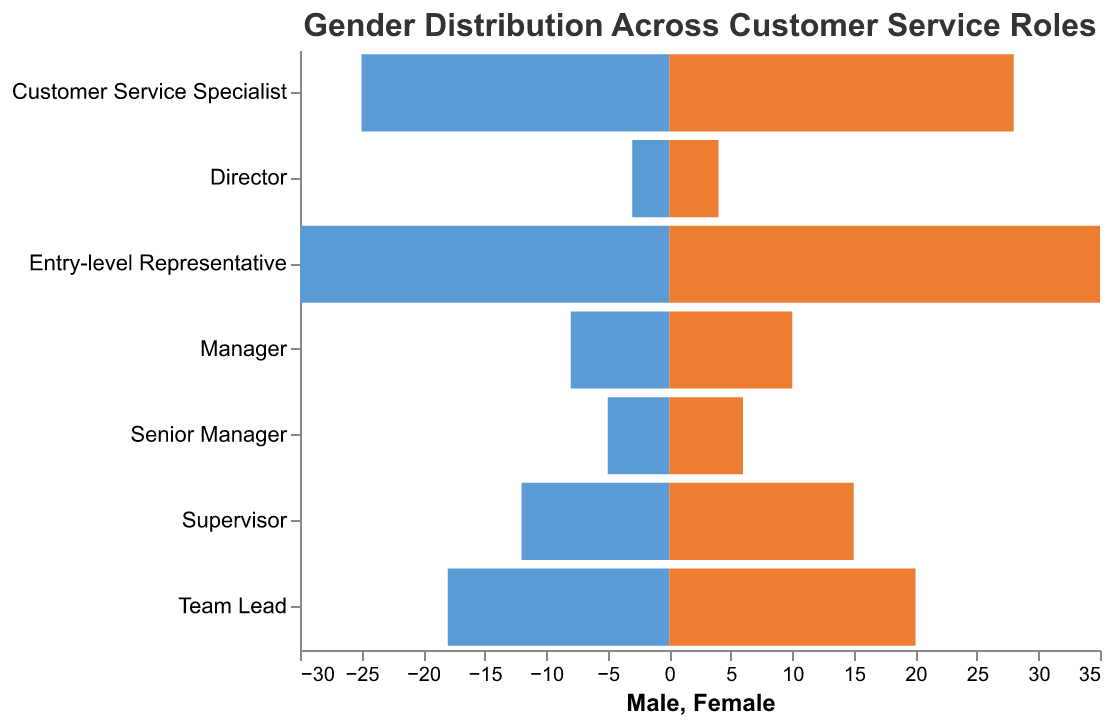What is the title of the figure? The title of the figure is displayed at the top and it reads "Gender Distribution Across Customer Service Roles".
Answer: Gender Distribution Across Customer Service Roles What are the colors used to represent Male and Female in the figure? The figure uses two different colors to represent Male and Female. The bars for Male are colored blue, and the bars for Female are colored orange.
Answer: Blue and Orange Which role has the highest number of females? Looking at the lengths of the orange bars, the Entry-level Representative has the longest bar, indicating the highest number of females.
Answer: Entry-level Representative How many males are in the Supervisor role? The blue bar corresponding to the Supervisor role represents 12 males, as indicated by the value next to it.
Answer: 12 Which role has the smallest gender gap? Comparing the bars for each role, the Customer Service Specialist has closely matched lengths for males (25) and females (28), indicating the smallest gap.
Answer: Customer Service Specialist How many females are there in the Manager role? The figure shows that the orange bar for the Manager role corresponds to a value of 10, indicating there are 10 females.
Answer: 10 What is the total number of Entry-level Representatives? Adding the number of males (30) and females (35) for the Entry-level Representative role gives the total number of Entry-level Representatives as 30 + 35 = 65.
Answer: 65 How many more females are there than males in the Supervisor role? The red bar for females (15) and the blue bar for males (12) in the Supervisor role shows a difference of 15 - 12 = 3. There are 3 more females than males.
Answer: 3 What is the average number of males across all roles? Adding the number of males in all roles and then dividing by the number of roles: (30 + 25 + 18 + 12 + 8 + 5 + 3) / 7 = 101 / 7 ≈ 14.43.
Answer: Approximately 14.43 